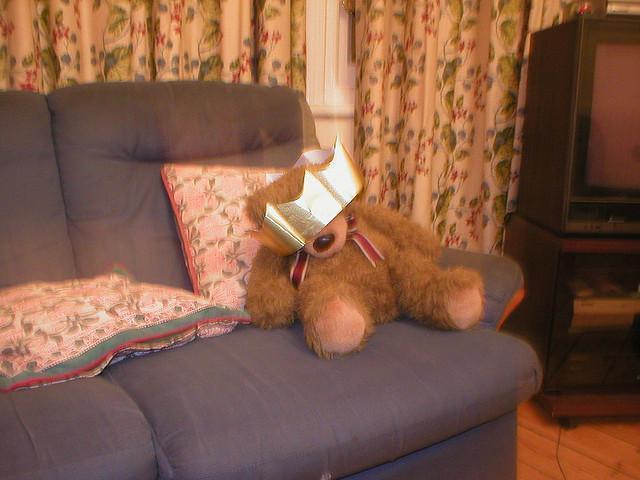How many pillows are on the couch?
Give a very brief answer. 2. How many men are in the picture?
Give a very brief answer. 0. 